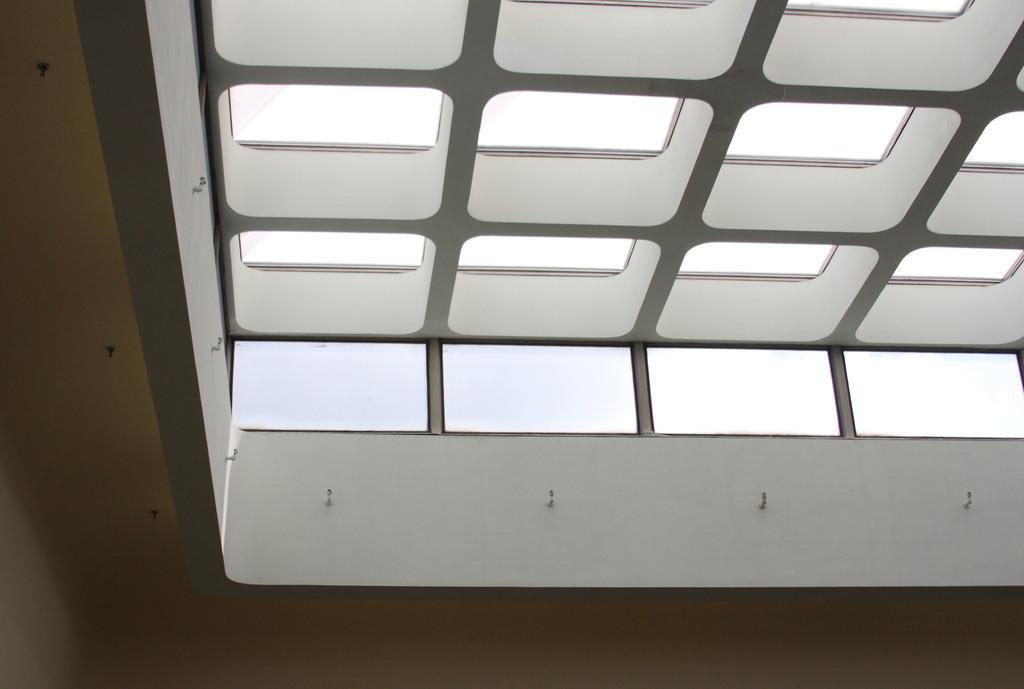Describe this image in one or two sentences. In the picture we can see a ceiling which is designed as a window. 